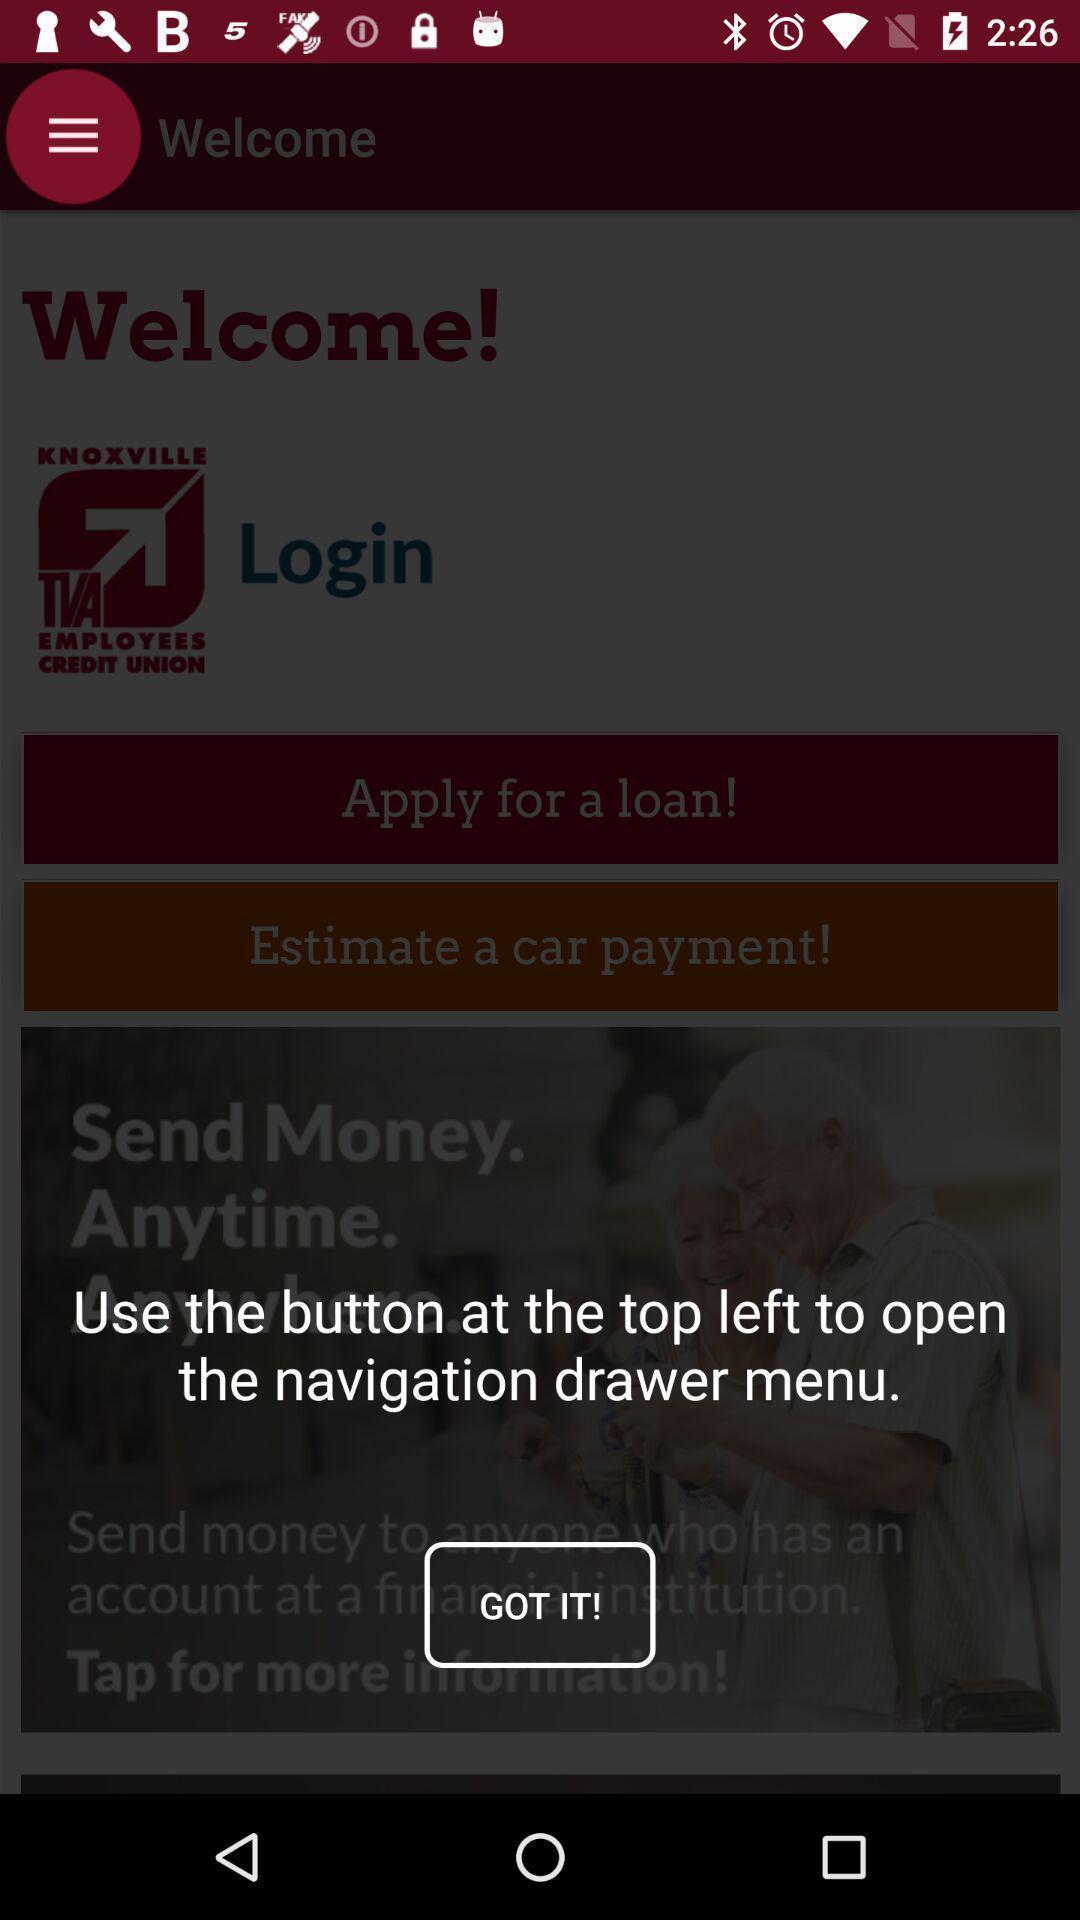Describe the visual elements of this screenshot. Welcome page. 